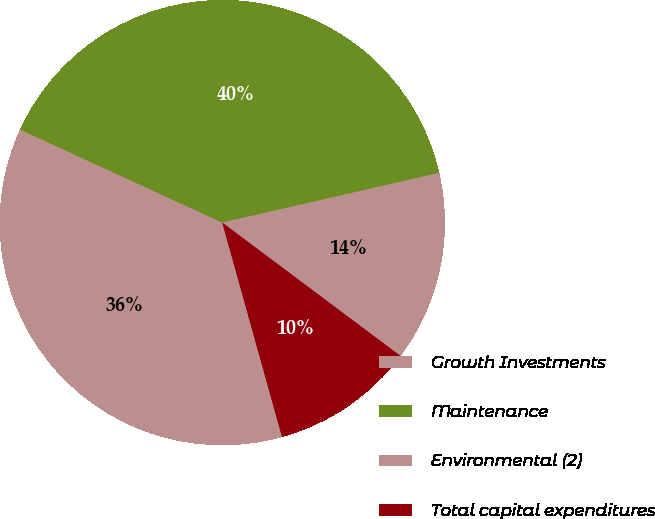Convert chart. <chart><loc_0><loc_0><loc_500><loc_500><pie_chart><fcel>Growth Investments<fcel>Maintenance<fcel>Environmental (2)<fcel>Total capital expenditures<nl><fcel>36.19%<fcel>39.55%<fcel>13.81%<fcel>10.45%<nl></chart> 